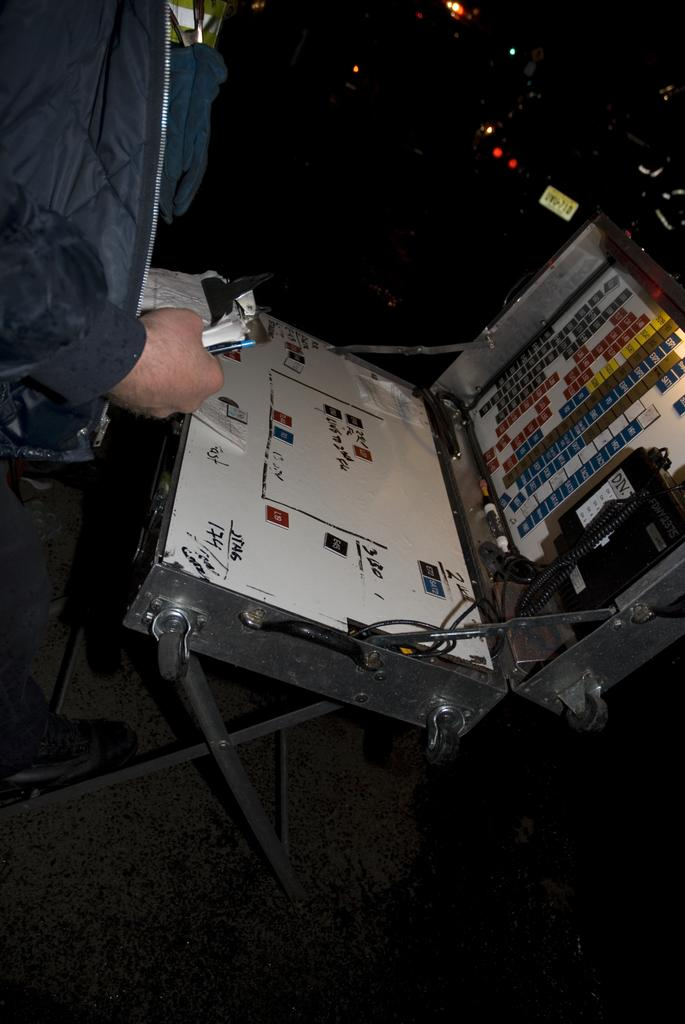Who or what is present in the image? There is a person in the image. What object is in front of the person? There is a box in front of the person. What can be seen in the background of the image? There are lights visible in the background of the image. What type of butter is being used by the person in the image? There is no butter present in the image. 